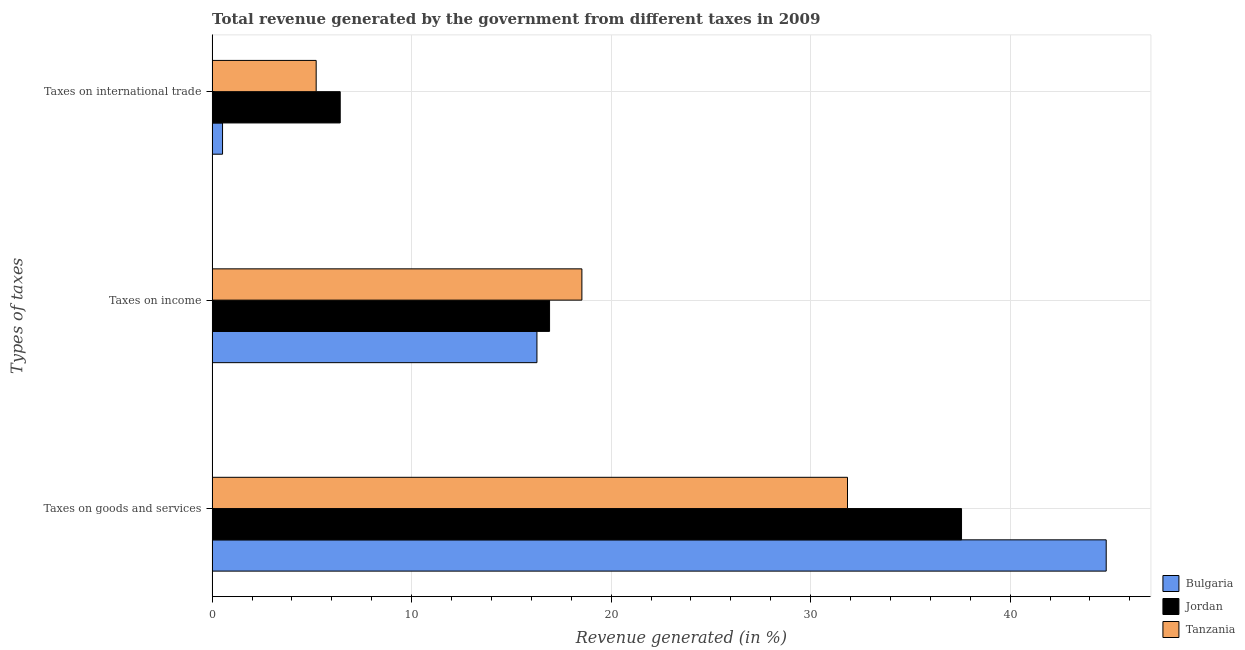How many different coloured bars are there?
Offer a very short reply. 3. How many groups of bars are there?
Provide a succinct answer. 3. Are the number of bars per tick equal to the number of legend labels?
Ensure brevity in your answer.  Yes. Are the number of bars on each tick of the Y-axis equal?
Make the answer very short. Yes. How many bars are there on the 3rd tick from the top?
Give a very brief answer. 3. How many bars are there on the 1st tick from the bottom?
Offer a very short reply. 3. What is the label of the 2nd group of bars from the top?
Ensure brevity in your answer.  Taxes on income. What is the percentage of revenue generated by tax on international trade in Jordan?
Keep it short and to the point. 6.42. Across all countries, what is the maximum percentage of revenue generated by taxes on income?
Provide a short and direct response. 18.53. Across all countries, what is the minimum percentage of revenue generated by taxes on income?
Your answer should be very brief. 16.28. In which country was the percentage of revenue generated by tax on international trade maximum?
Provide a short and direct response. Jordan. In which country was the percentage of revenue generated by taxes on goods and services minimum?
Your response must be concise. Tanzania. What is the total percentage of revenue generated by taxes on income in the graph?
Offer a terse response. 51.73. What is the difference between the percentage of revenue generated by taxes on income in Bulgaria and that in Tanzania?
Offer a terse response. -2.25. What is the difference between the percentage of revenue generated by taxes on goods and services in Bulgaria and the percentage of revenue generated by tax on international trade in Tanzania?
Ensure brevity in your answer.  39.6. What is the average percentage of revenue generated by tax on international trade per country?
Your answer should be compact. 4.05. What is the difference between the percentage of revenue generated by taxes on goods and services and percentage of revenue generated by taxes on income in Tanzania?
Provide a short and direct response. 13.31. In how many countries, is the percentage of revenue generated by taxes on income greater than 2 %?
Keep it short and to the point. 3. What is the ratio of the percentage of revenue generated by taxes on goods and services in Tanzania to that in Jordan?
Give a very brief answer. 0.85. What is the difference between the highest and the second highest percentage of revenue generated by taxes on income?
Ensure brevity in your answer.  1.62. What is the difference between the highest and the lowest percentage of revenue generated by taxes on goods and services?
Provide a short and direct response. 12.97. In how many countries, is the percentage of revenue generated by taxes on income greater than the average percentage of revenue generated by taxes on income taken over all countries?
Offer a terse response. 1. What does the 3rd bar from the bottom in Taxes on goods and services represents?
Make the answer very short. Tanzania. How many bars are there?
Offer a terse response. 9. Are all the bars in the graph horizontal?
Provide a short and direct response. Yes. How many countries are there in the graph?
Give a very brief answer. 3. Does the graph contain any zero values?
Provide a succinct answer. No. Does the graph contain grids?
Keep it short and to the point. Yes. How are the legend labels stacked?
Provide a succinct answer. Vertical. What is the title of the graph?
Offer a terse response. Total revenue generated by the government from different taxes in 2009. What is the label or title of the X-axis?
Keep it short and to the point. Revenue generated (in %). What is the label or title of the Y-axis?
Offer a very short reply. Types of taxes. What is the Revenue generated (in %) of Bulgaria in Taxes on goods and services?
Your answer should be compact. 44.81. What is the Revenue generated (in %) in Jordan in Taxes on goods and services?
Make the answer very short. 37.56. What is the Revenue generated (in %) of Tanzania in Taxes on goods and services?
Ensure brevity in your answer.  31.85. What is the Revenue generated (in %) of Bulgaria in Taxes on income?
Your answer should be compact. 16.28. What is the Revenue generated (in %) in Jordan in Taxes on income?
Give a very brief answer. 16.91. What is the Revenue generated (in %) in Tanzania in Taxes on income?
Your answer should be compact. 18.53. What is the Revenue generated (in %) in Bulgaria in Taxes on international trade?
Give a very brief answer. 0.52. What is the Revenue generated (in %) of Jordan in Taxes on international trade?
Make the answer very short. 6.42. What is the Revenue generated (in %) in Tanzania in Taxes on international trade?
Give a very brief answer. 5.22. Across all Types of taxes, what is the maximum Revenue generated (in %) in Bulgaria?
Keep it short and to the point. 44.81. Across all Types of taxes, what is the maximum Revenue generated (in %) of Jordan?
Ensure brevity in your answer.  37.56. Across all Types of taxes, what is the maximum Revenue generated (in %) of Tanzania?
Give a very brief answer. 31.85. Across all Types of taxes, what is the minimum Revenue generated (in %) of Bulgaria?
Your answer should be very brief. 0.52. Across all Types of taxes, what is the minimum Revenue generated (in %) in Jordan?
Offer a terse response. 6.42. Across all Types of taxes, what is the minimum Revenue generated (in %) of Tanzania?
Make the answer very short. 5.22. What is the total Revenue generated (in %) of Bulgaria in the graph?
Offer a terse response. 61.62. What is the total Revenue generated (in %) of Jordan in the graph?
Your answer should be compact. 60.9. What is the total Revenue generated (in %) of Tanzania in the graph?
Your answer should be very brief. 55.6. What is the difference between the Revenue generated (in %) of Bulgaria in Taxes on goods and services and that in Taxes on income?
Make the answer very short. 28.53. What is the difference between the Revenue generated (in %) of Jordan in Taxes on goods and services and that in Taxes on income?
Give a very brief answer. 20.65. What is the difference between the Revenue generated (in %) of Tanzania in Taxes on goods and services and that in Taxes on income?
Make the answer very short. 13.31. What is the difference between the Revenue generated (in %) in Bulgaria in Taxes on goods and services and that in Taxes on international trade?
Make the answer very short. 44.29. What is the difference between the Revenue generated (in %) in Jordan in Taxes on goods and services and that in Taxes on international trade?
Offer a very short reply. 31.14. What is the difference between the Revenue generated (in %) of Tanzania in Taxes on goods and services and that in Taxes on international trade?
Keep it short and to the point. 26.63. What is the difference between the Revenue generated (in %) in Bulgaria in Taxes on income and that in Taxes on international trade?
Make the answer very short. 15.76. What is the difference between the Revenue generated (in %) in Jordan in Taxes on income and that in Taxes on international trade?
Make the answer very short. 10.49. What is the difference between the Revenue generated (in %) in Tanzania in Taxes on income and that in Taxes on international trade?
Provide a short and direct response. 13.32. What is the difference between the Revenue generated (in %) in Bulgaria in Taxes on goods and services and the Revenue generated (in %) in Jordan in Taxes on income?
Give a very brief answer. 27.9. What is the difference between the Revenue generated (in %) of Bulgaria in Taxes on goods and services and the Revenue generated (in %) of Tanzania in Taxes on income?
Ensure brevity in your answer.  26.28. What is the difference between the Revenue generated (in %) of Jordan in Taxes on goods and services and the Revenue generated (in %) of Tanzania in Taxes on income?
Provide a short and direct response. 19.03. What is the difference between the Revenue generated (in %) of Bulgaria in Taxes on goods and services and the Revenue generated (in %) of Jordan in Taxes on international trade?
Keep it short and to the point. 38.39. What is the difference between the Revenue generated (in %) of Bulgaria in Taxes on goods and services and the Revenue generated (in %) of Tanzania in Taxes on international trade?
Ensure brevity in your answer.  39.6. What is the difference between the Revenue generated (in %) of Jordan in Taxes on goods and services and the Revenue generated (in %) of Tanzania in Taxes on international trade?
Your answer should be very brief. 32.35. What is the difference between the Revenue generated (in %) in Bulgaria in Taxes on income and the Revenue generated (in %) in Jordan in Taxes on international trade?
Ensure brevity in your answer.  9.86. What is the difference between the Revenue generated (in %) of Bulgaria in Taxes on income and the Revenue generated (in %) of Tanzania in Taxes on international trade?
Your answer should be compact. 11.07. What is the difference between the Revenue generated (in %) of Jordan in Taxes on income and the Revenue generated (in %) of Tanzania in Taxes on international trade?
Offer a terse response. 11.7. What is the average Revenue generated (in %) of Bulgaria per Types of taxes?
Provide a succinct answer. 20.54. What is the average Revenue generated (in %) in Jordan per Types of taxes?
Give a very brief answer. 20.3. What is the average Revenue generated (in %) in Tanzania per Types of taxes?
Your response must be concise. 18.53. What is the difference between the Revenue generated (in %) of Bulgaria and Revenue generated (in %) of Jordan in Taxes on goods and services?
Offer a very short reply. 7.25. What is the difference between the Revenue generated (in %) in Bulgaria and Revenue generated (in %) in Tanzania in Taxes on goods and services?
Your answer should be compact. 12.97. What is the difference between the Revenue generated (in %) of Jordan and Revenue generated (in %) of Tanzania in Taxes on goods and services?
Provide a short and direct response. 5.72. What is the difference between the Revenue generated (in %) of Bulgaria and Revenue generated (in %) of Jordan in Taxes on income?
Provide a succinct answer. -0.63. What is the difference between the Revenue generated (in %) of Bulgaria and Revenue generated (in %) of Tanzania in Taxes on income?
Make the answer very short. -2.25. What is the difference between the Revenue generated (in %) in Jordan and Revenue generated (in %) in Tanzania in Taxes on income?
Your response must be concise. -1.62. What is the difference between the Revenue generated (in %) of Bulgaria and Revenue generated (in %) of Jordan in Taxes on international trade?
Provide a short and direct response. -5.9. What is the difference between the Revenue generated (in %) of Bulgaria and Revenue generated (in %) of Tanzania in Taxes on international trade?
Offer a terse response. -4.69. What is the difference between the Revenue generated (in %) in Jordan and Revenue generated (in %) in Tanzania in Taxes on international trade?
Provide a succinct answer. 1.21. What is the ratio of the Revenue generated (in %) in Bulgaria in Taxes on goods and services to that in Taxes on income?
Your answer should be very brief. 2.75. What is the ratio of the Revenue generated (in %) of Jordan in Taxes on goods and services to that in Taxes on income?
Offer a very short reply. 2.22. What is the ratio of the Revenue generated (in %) in Tanzania in Taxes on goods and services to that in Taxes on income?
Provide a succinct answer. 1.72. What is the ratio of the Revenue generated (in %) in Bulgaria in Taxes on goods and services to that in Taxes on international trade?
Ensure brevity in your answer.  85.82. What is the ratio of the Revenue generated (in %) in Jordan in Taxes on goods and services to that in Taxes on international trade?
Offer a very short reply. 5.85. What is the ratio of the Revenue generated (in %) of Tanzania in Taxes on goods and services to that in Taxes on international trade?
Make the answer very short. 6.11. What is the ratio of the Revenue generated (in %) of Bulgaria in Taxes on income to that in Taxes on international trade?
Your answer should be compact. 31.18. What is the ratio of the Revenue generated (in %) of Jordan in Taxes on income to that in Taxes on international trade?
Provide a short and direct response. 2.63. What is the ratio of the Revenue generated (in %) of Tanzania in Taxes on income to that in Taxes on international trade?
Make the answer very short. 3.55. What is the difference between the highest and the second highest Revenue generated (in %) of Bulgaria?
Provide a succinct answer. 28.53. What is the difference between the highest and the second highest Revenue generated (in %) in Jordan?
Keep it short and to the point. 20.65. What is the difference between the highest and the second highest Revenue generated (in %) in Tanzania?
Your answer should be very brief. 13.31. What is the difference between the highest and the lowest Revenue generated (in %) of Bulgaria?
Your answer should be compact. 44.29. What is the difference between the highest and the lowest Revenue generated (in %) in Jordan?
Offer a terse response. 31.14. What is the difference between the highest and the lowest Revenue generated (in %) in Tanzania?
Offer a very short reply. 26.63. 